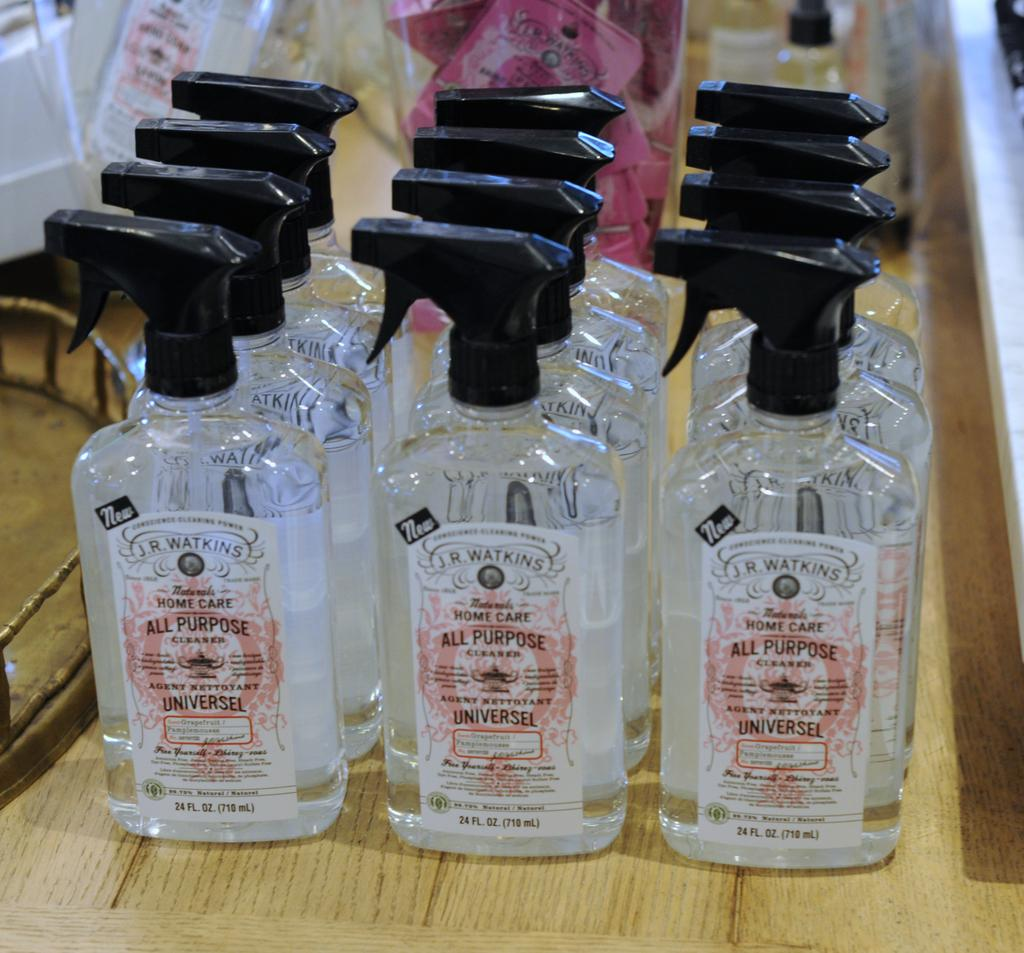<image>
Write a terse but informative summary of the picture. Several bottles of all purpose cleaner sit on a table. 